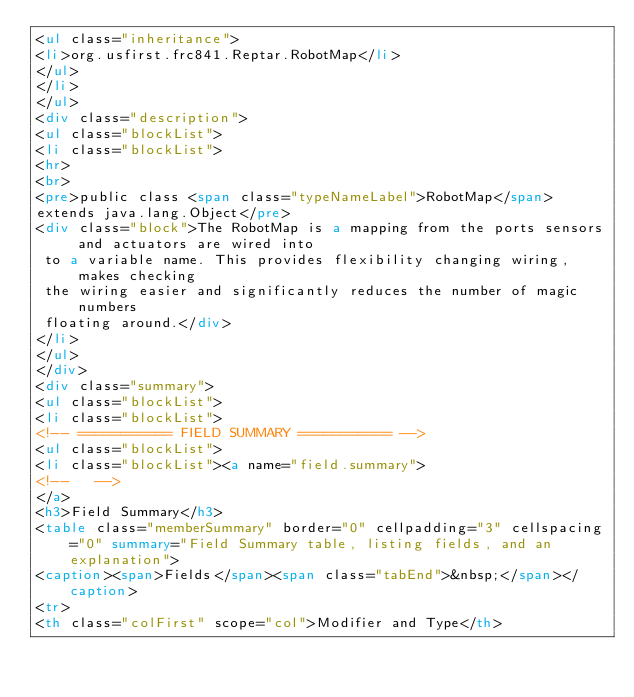Convert code to text. <code><loc_0><loc_0><loc_500><loc_500><_HTML_><ul class="inheritance">
<li>org.usfirst.frc841.Reptar.RobotMap</li>
</ul>
</li>
</ul>
<div class="description">
<ul class="blockList">
<li class="blockList">
<hr>
<br>
<pre>public class <span class="typeNameLabel">RobotMap</span>
extends java.lang.Object</pre>
<div class="block">The RobotMap is a mapping from the ports sensors and actuators are wired into
 to a variable name. This provides flexibility changing wiring, makes checking
 the wiring easier and significantly reduces the number of magic numbers
 floating around.</div>
</li>
</ul>
</div>
<div class="summary">
<ul class="blockList">
<li class="blockList">
<!-- =========== FIELD SUMMARY =========== -->
<ul class="blockList">
<li class="blockList"><a name="field.summary">
<!--   -->
</a>
<h3>Field Summary</h3>
<table class="memberSummary" border="0" cellpadding="3" cellspacing="0" summary="Field Summary table, listing fields, and an explanation">
<caption><span>Fields</span><span class="tabEnd">&nbsp;</span></caption>
<tr>
<th class="colFirst" scope="col">Modifier and Type</th></code> 